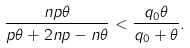Convert formula to latex. <formula><loc_0><loc_0><loc_500><loc_500>\frac { n p \theta } { p \theta + 2 n p - n \theta } < \frac { q _ { 0 } \theta } { q _ { 0 } + \theta } .</formula> 